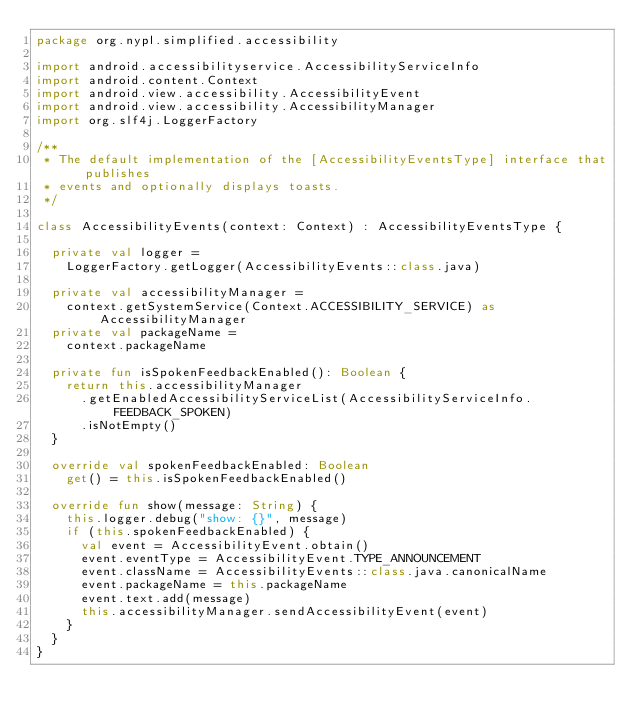<code> <loc_0><loc_0><loc_500><loc_500><_Kotlin_>package org.nypl.simplified.accessibility

import android.accessibilityservice.AccessibilityServiceInfo
import android.content.Context
import android.view.accessibility.AccessibilityEvent
import android.view.accessibility.AccessibilityManager
import org.slf4j.LoggerFactory

/**
 * The default implementation of the [AccessibilityEventsType] interface that publishes
 * events and optionally displays toasts.
 */

class AccessibilityEvents(context: Context) : AccessibilityEventsType {

  private val logger =
    LoggerFactory.getLogger(AccessibilityEvents::class.java)

  private val accessibilityManager =
    context.getSystemService(Context.ACCESSIBILITY_SERVICE) as AccessibilityManager
  private val packageName =
    context.packageName

  private fun isSpokenFeedbackEnabled(): Boolean {
    return this.accessibilityManager
      .getEnabledAccessibilityServiceList(AccessibilityServiceInfo.FEEDBACK_SPOKEN)
      .isNotEmpty()
  }

  override val spokenFeedbackEnabled: Boolean
    get() = this.isSpokenFeedbackEnabled()

  override fun show(message: String) {
    this.logger.debug("show: {}", message)
    if (this.spokenFeedbackEnabled) {
      val event = AccessibilityEvent.obtain()
      event.eventType = AccessibilityEvent.TYPE_ANNOUNCEMENT
      event.className = AccessibilityEvents::class.java.canonicalName
      event.packageName = this.packageName
      event.text.add(message)
      this.accessibilityManager.sendAccessibilityEvent(event)
    }
  }
}
</code> 